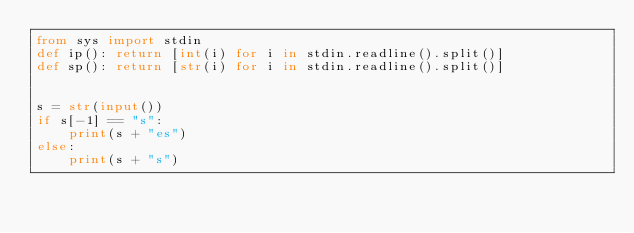<code> <loc_0><loc_0><loc_500><loc_500><_Python_>from sys import stdin
def ip(): return [int(i) for i in stdin.readline().split()]
def sp(): return [str(i) for i in stdin.readline().split()]


s = str(input())
if s[-1] == "s":
    print(s + "es")
else:
    print(s + "s")</code> 